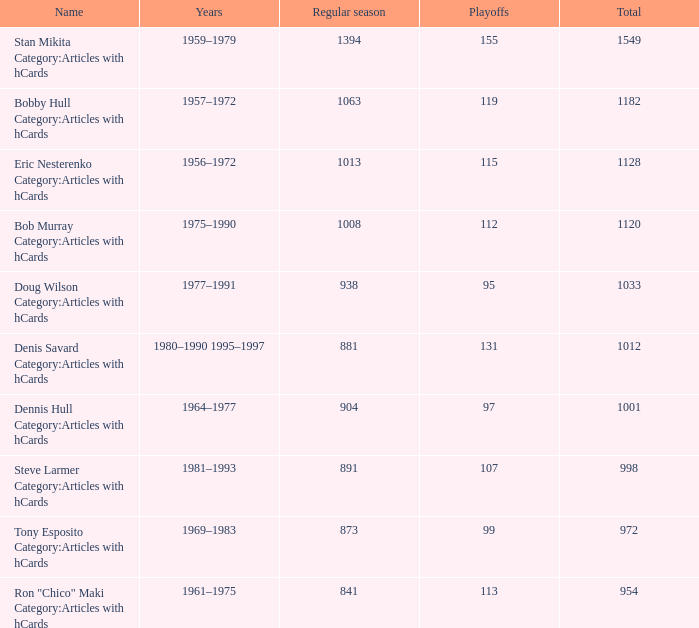What is the factor by which 1063 regular season games are more than 119 playoff games? 0.0. 